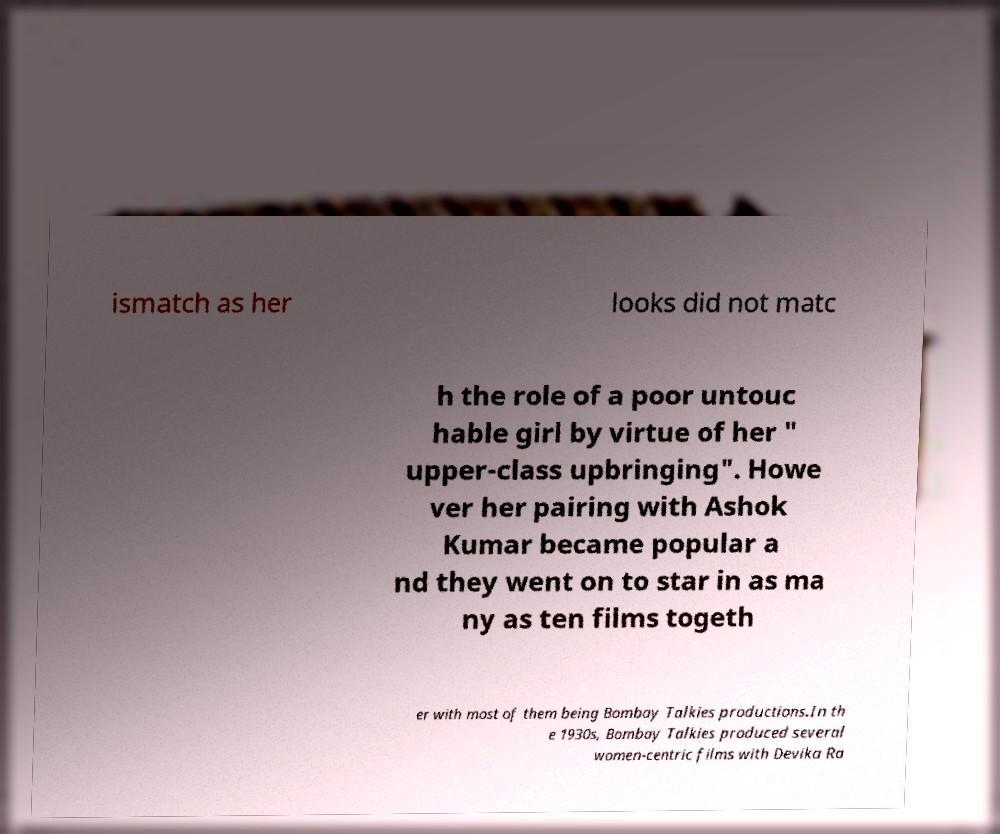Please read and relay the text visible in this image. What does it say? ismatch as her looks did not matc h the role of a poor untouc hable girl by virtue of her " upper-class upbringing". Howe ver her pairing with Ashok Kumar became popular a nd they went on to star in as ma ny as ten films togeth er with most of them being Bombay Talkies productions.In th e 1930s, Bombay Talkies produced several women-centric films with Devika Ra 